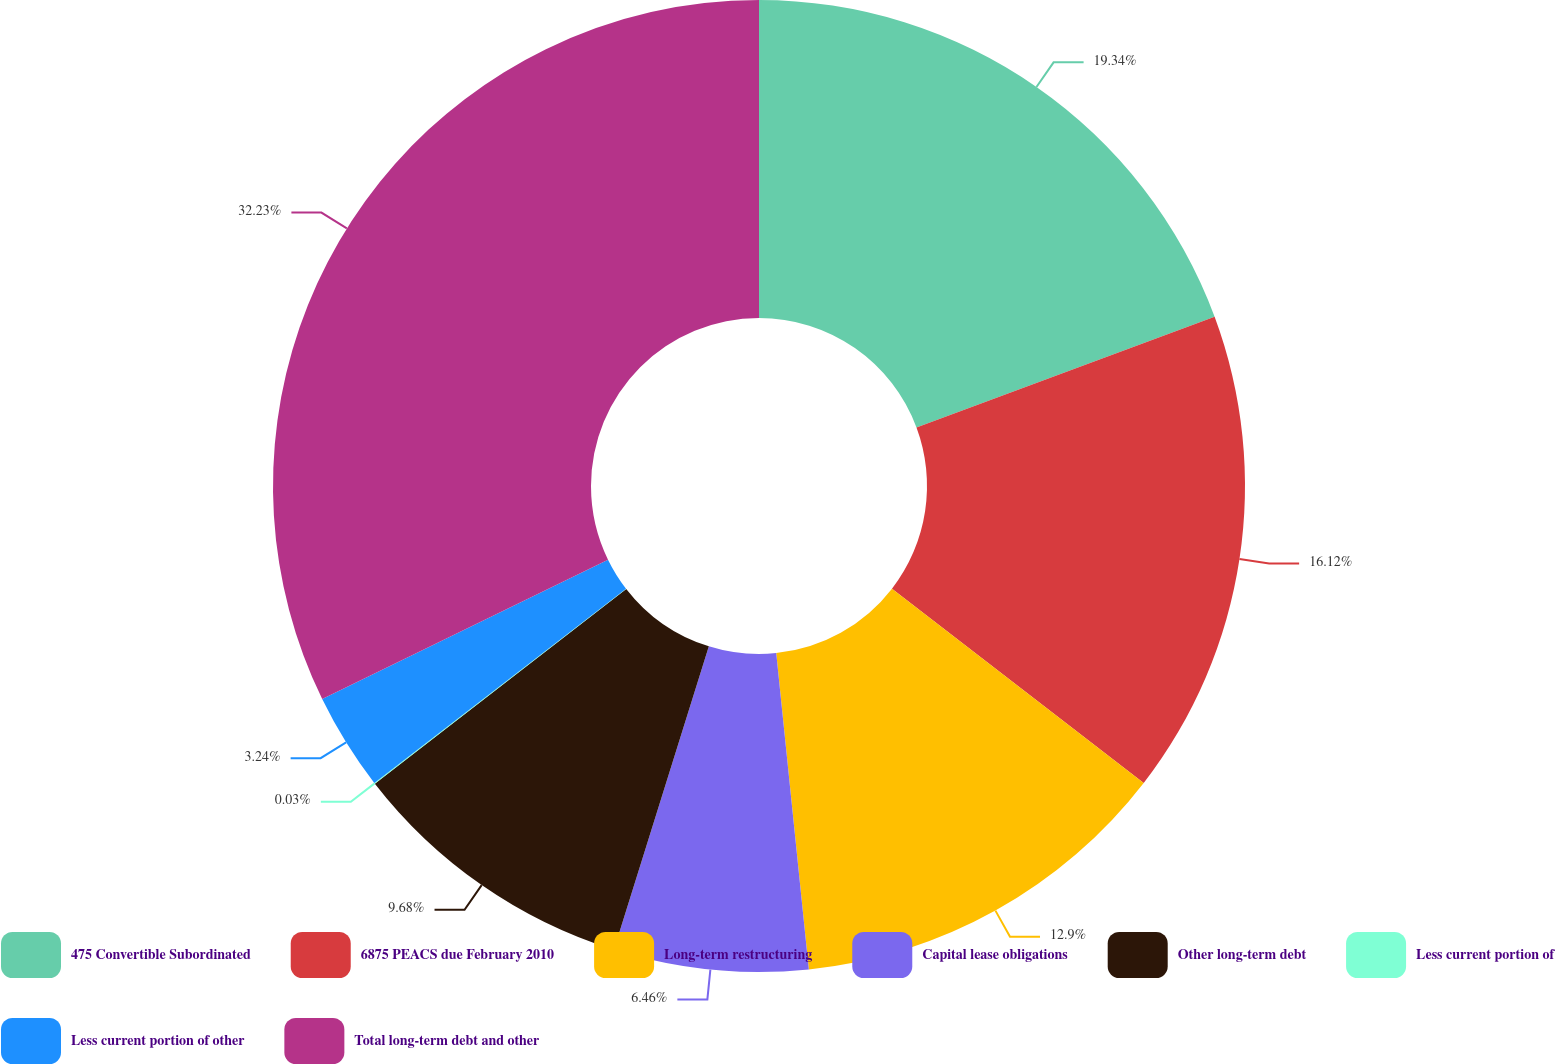Convert chart to OTSL. <chart><loc_0><loc_0><loc_500><loc_500><pie_chart><fcel>475 Convertible Subordinated<fcel>6875 PEACS due February 2010<fcel>Long-term restructuring<fcel>Capital lease obligations<fcel>Other long-term debt<fcel>Less current portion of<fcel>Less current portion of other<fcel>Total long-term debt and other<nl><fcel>19.34%<fcel>16.12%<fcel>12.9%<fcel>6.46%<fcel>9.68%<fcel>0.03%<fcel>3.24%<fcel>32.22%<nl></chart> 